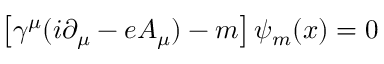Convert formula to latex. <formula><loc_0><loc_0><loc_500><loc_500>\left [ \gamma ^ { \mu } ( i \partial _ { \mu } - e A _ { \mu } ) - m \right ] \psi _ { m } ( x ) = 0</formula> 